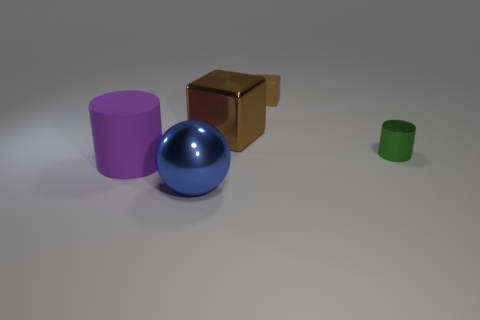There is a brown thing that is the same material as the tiny green object; what is its shape?
Your response must be concise. Cube. Are the tiny green object and the purple thing made of the same material?
Keep it short and to the point. No. Is the number of large brown blocks that are to the left of the rubber block less than the number of green metallic things behind the purple rubber cylinder?
Your response must be concise. No. There is a metal thing that is the same color as the tiny rubber object; what size is it?
Give a very brief answer. Large. There is a cylinder behind the large object on the left side of the large blue thing; what number of metallic cylinders are in front of it?
Your answer should be very brief. 0. Do the small matte cube and the shiny block have the same color?
Make the answer very short. Yes. Are there any big objects of the same color as the large cylinder?
Ensure brevity in your answer.  No. What is the color of the metallic block that is the same size as the purple thing?
Provide a succinct answer. Brown. Are there any small rubber things that have the same shape as the tiny green metallic thing?
Your answer should be compact. No. What is the shape of the big shiny thing that is the same color as the matte cube?
Offer a very short reply. Cube. 